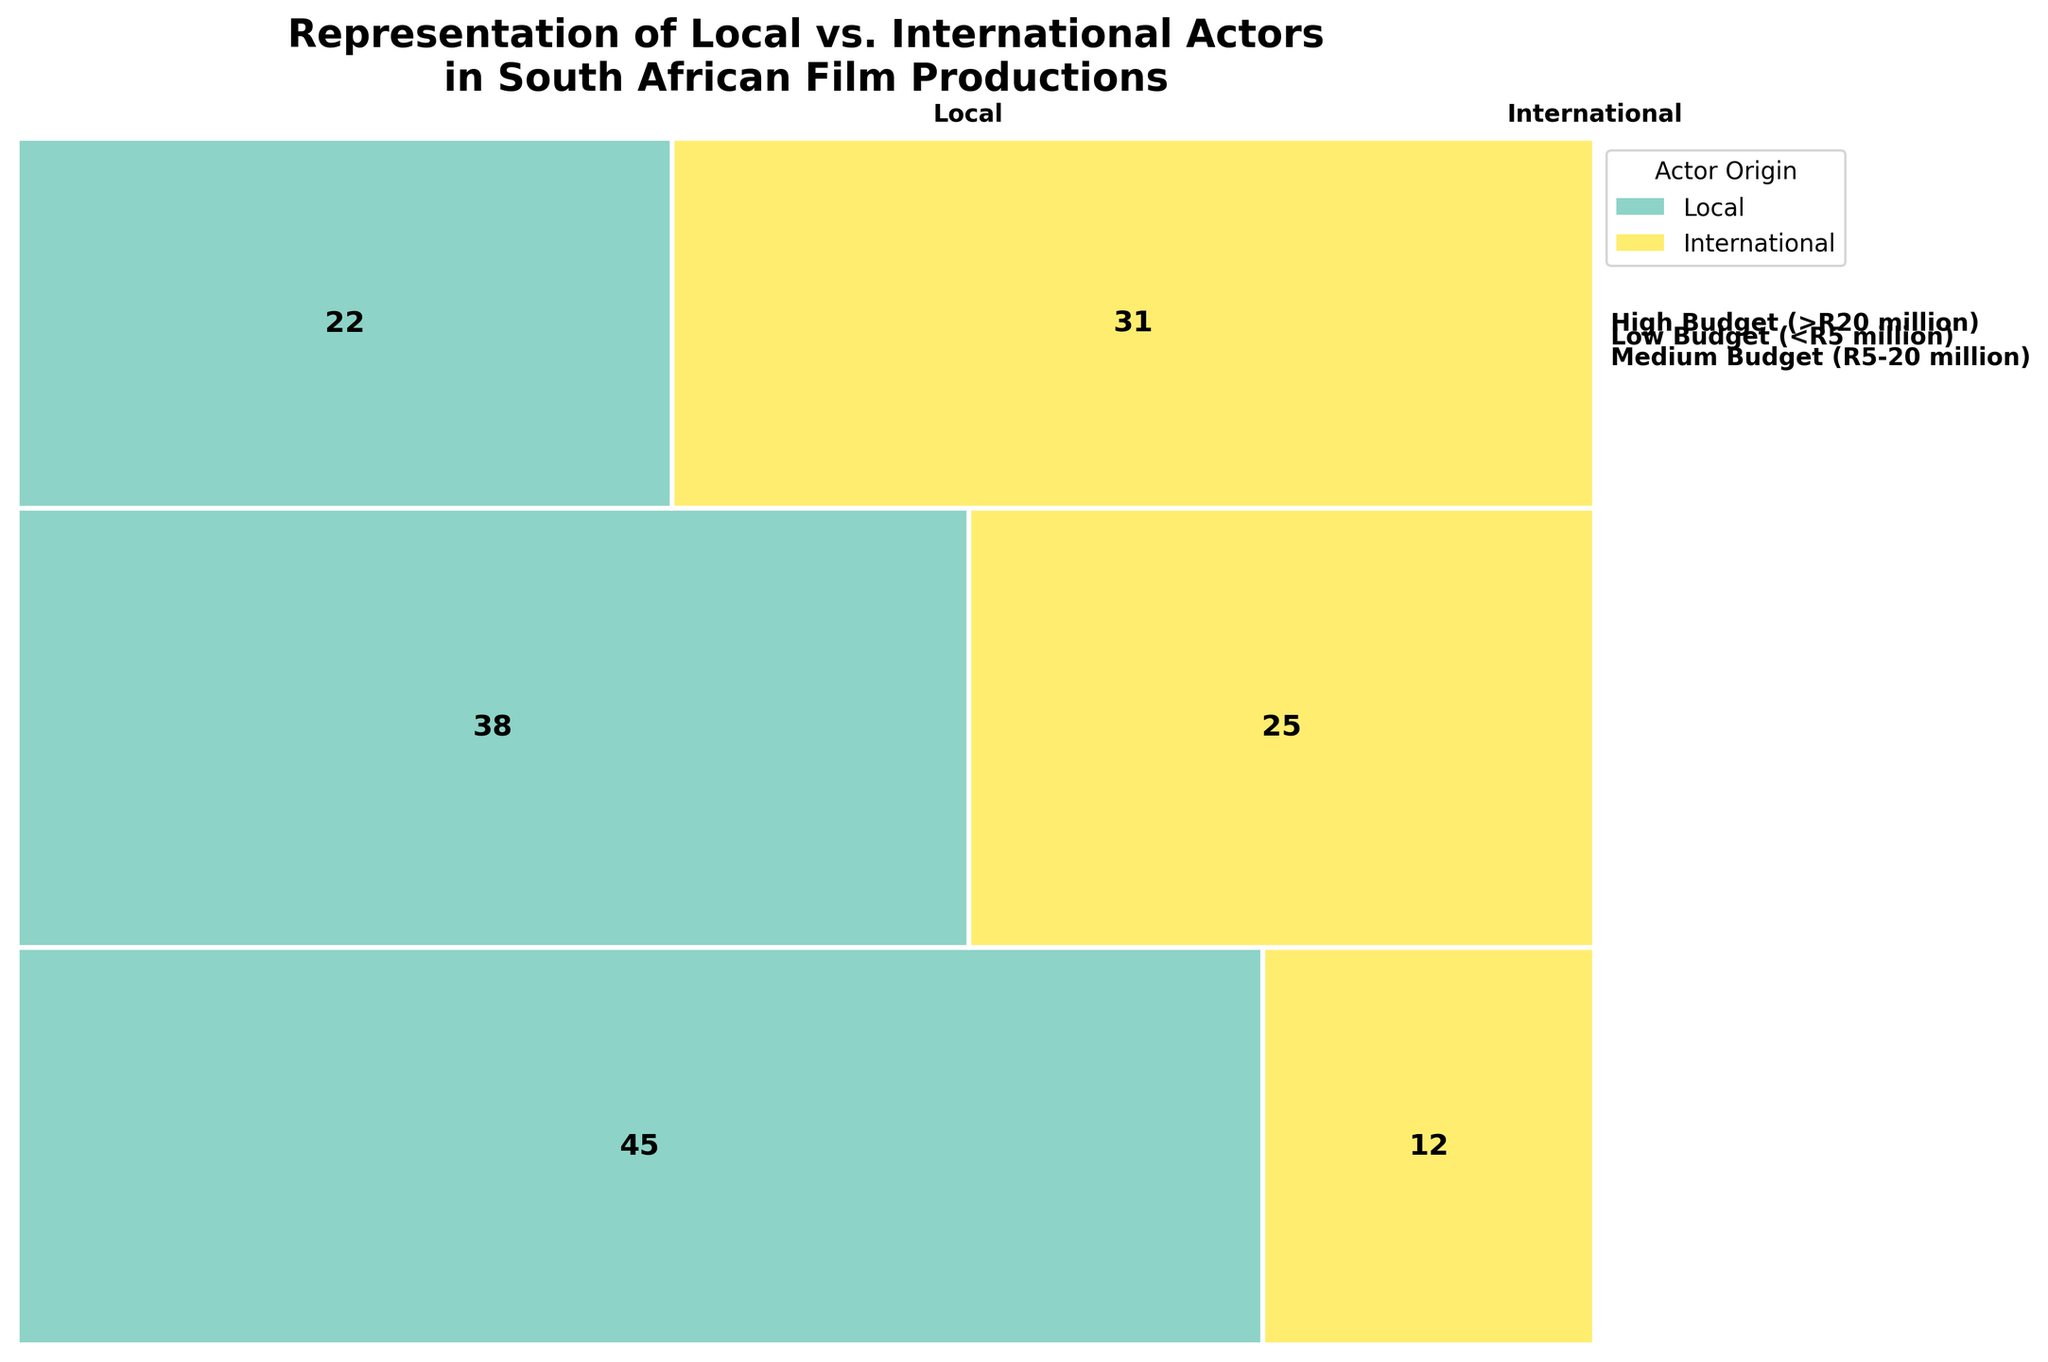What is the title of the figure? The title is located at the top of the figure and summarizes the main insight visually represented. It reads "Representation of Local vs. International Actors in South African Film Productions".
Answer: Representation of Local vs. International Actors in South African Film Productions How many local actors are in high-budget films? The high-budget section of the plot lists the counts for local and international actors. For local actors, the count is shown clearly on the plot.
Answer: 22 Which budget category has the highest total number of actors? Summing the counts of local and international actors within each budget range gives us the total actors. The largest total is found by visual inspection.
Answer: Low Budget (<R5 million) How many more international actors are in high-budget films compared to medium-budget films? Comparing the counts of international actors for these two categories involves simple subtraction. High-budget has 31 and medium-budget has 25. The difference is 31 - 25.
Answer: 6 Which actor origin is more represented in medium-budget films? By comparing the counts for local and international actors in medium-budget films, we note that local actors (38) are more represented than international actors (25).
Answer: Local What is the sum of local actors across all budget categories? Adding the counts of local actors from all categories: 45 (low budget) + 38 (medium budget) + 22 (high budget) gives the total.
Answer: 105 What is the proportion of international actors in low-budget films relative to the total number of actors in that category? To find the proportion, divide the number of international actors in low-budget films by the total actors in that category. Calculation: 12 / (45 + 12).
Answer: 0.21 Which budget category has the largest proportion of international actors? Calculating the proportion of international actors within each budget range involves dividing international counts by the total counts in those categories. The highest proportion identifies the category.
Answer: High Budget (>R20 million) Are there more local or international actors in high-budget films? By comparing the counts of local and international actors for high-budget films, we see that there are more international actors (31) than local actors (22).
Answer: International What is the average count of international actors in all budget ranges? Summing the counts of international actors across all budget ranges and dividing by the number of budget ranges gives the average. Calculation: (12 + 25 + 31)/3.
Answer: 22.67 